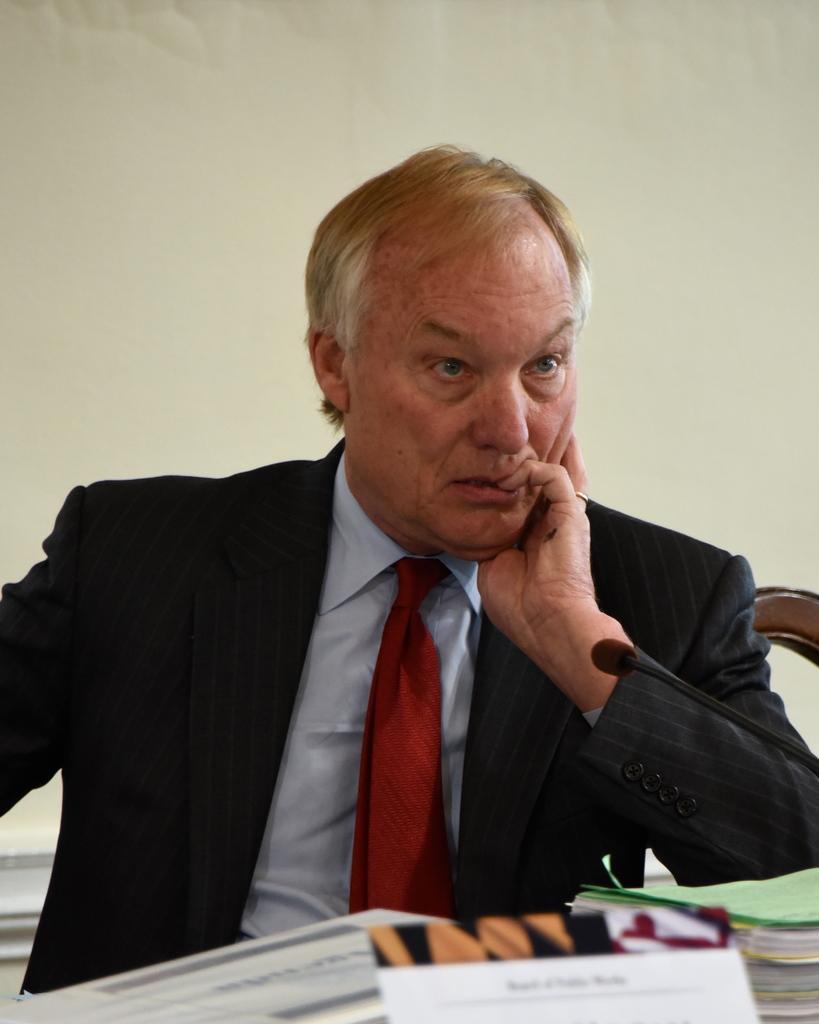How would you summarize this image in a sentence or two? In this image I can see a man and I can see he is wearing formal dress. In the front of him I can see few papers, a mic and few other things. I can also see something is written on the board and in the background I can see few other things. 